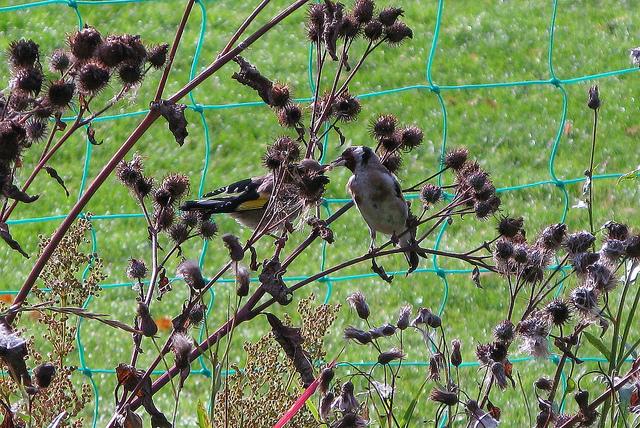What color is the fence?
Keep it brief. Green. What kind of tree is this?
Keep it brief. Maple. What are the birds doing?
Be succinct. Eating. How many birds are there?
Keep it brief. 2. 